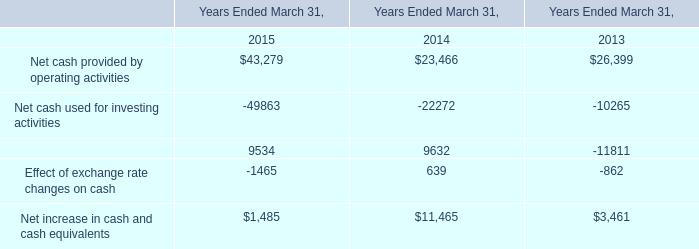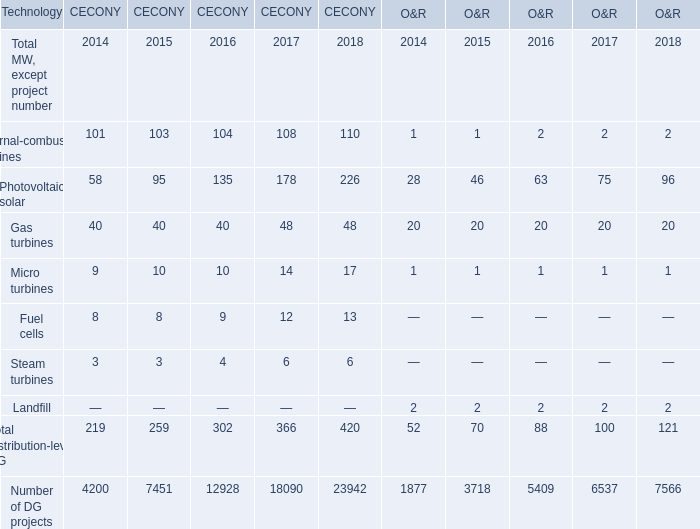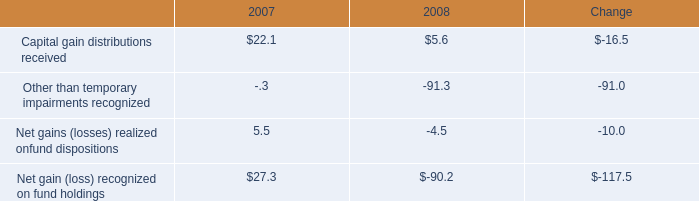what were the total occupancy and facility costs in 2007 , in millions of dollars? 
Computations: (18 / 12%)
Answer: 150.0. 